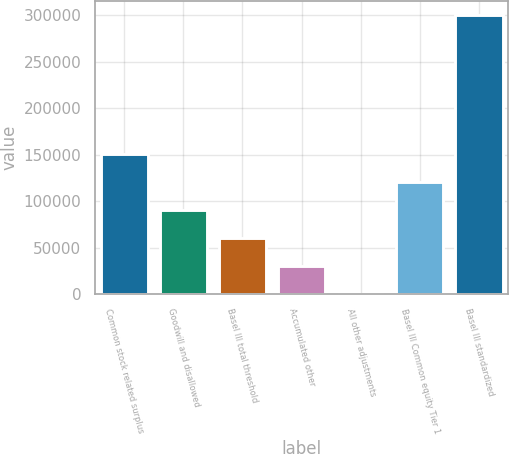<chart> <loc_0><loc_0><loc_500><loc_500><bar_chart><fcel>Common stock related surplus<fcel>Goodwill and disallowed<fcel>Basel III total threshold<fcel>Accumulated other<fcel>All other adjustments<fcel>Basel III Common equity Tier 1<fcel>Basel III standardized<nl><fcel>150374<fcel>90309.7<fcel>60277.8<fcel>30245.9<fcel>214<fcel>120342<fcel>300533<nl></chart> 